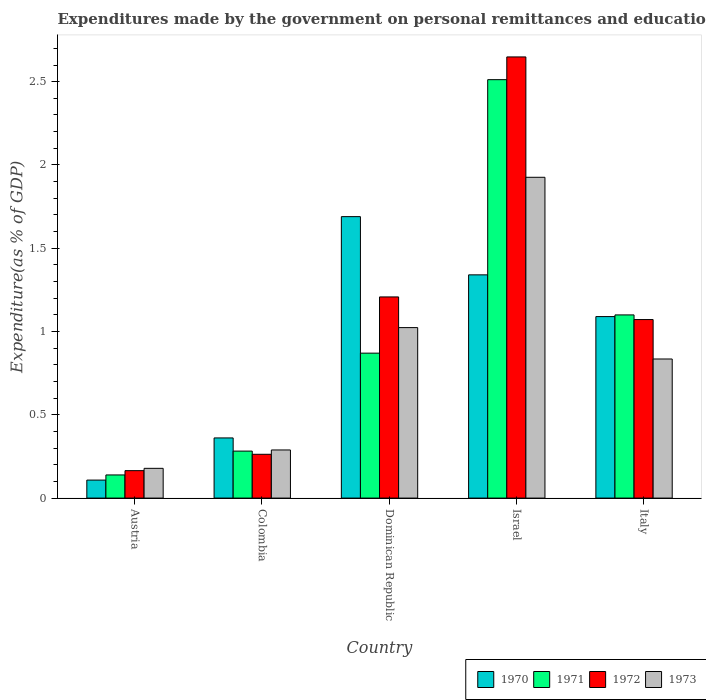How many different coloured bars are there?
Ensure brevity in your answer.  4. Are the number of bars per tick equal to the number of legend labels?
Provide a succinct answer. Yes. How many bars are there on the 1st tick from the left?
Make the answer very short. 4. How many bars are there on the 2nd tick from the right?
Make the answer very short. 4. What is the label of the 3rd group of bars from the left?
Provide a short and direct response. Dominican Republic. What is the expenditures made by the government on personal remittances and education in 1970 in Austria?
Your response must be concise. 0.11. Across all countries, what is the maximum expenditures made by the government on personal remittances and education in 1970?
Your response must be concise. 1.69. Across all countries, what is the minimum expenditures made by the government on personal remittances and education in 1973?
Give a very brief answer. 0.18. In which country was the expenditures made by the government on personal remittances and education in 1972 maximum?
Your answer should be very brief. Israel. What is the total expenditures made by the government on personal remittances and education in 1972 in the graph?
Provide a succinct answer. 5.36. What is the difference between the expenditures made by the government on personal remittances and education in 1970 in Israel and that in Italy?
Your answer should be compact. 0.25. What is the difference between the expenditures made by the government on personal remittances and education in 1973 in Italy and the expenditures made by the government on personal remittances and education in 1972 in Colombia?
Your answer should be very brief. 0.57. What is the average expenditures made by the government on personal remittances and education in 1973 per country?
Your answer should be compact. 0.85. What is the difference between the expenditures made by the government on personal remittances and education of/in 1972 and expenditures made by the government on personal remittances and education of/in 1971 in Colombia?
Provide a succinct answer. -0.02. What is the ratio of the expenditures made by the government on personal remittances and education in 1972 in Colombia to that in Dominican Republic?
Ensure brevity in your answer.  0.22. Is the difference between the expenditures made by the government on personal remittances and education in 1972 in Dominican Republic and Israel greater than the difference between the expenditures made by the government on personal remittances and education in 1971 in Dominican Republic and Israel?
Give a very brief answer. Yes. What is the difference between the highest and the second highest expenditures made by the government on personal remittances and education in 1973?
Offer a very short reply. -1.09. What is the difference between the highest and the lowest expenditures made by the government on personal remittances and education in 1973?
Make the answer very short. 1.75. In how many countries, is the expenditures made by the government on personal remittances and education in 1973 greater than the average expenditures made by the government on personal remittances and education in 1973 taken over all countries?
Provide a short and direct response. 2. What is the difference between two consecutive major ticks on the Y-axis?
Keep it short and to the point. 0.5. Are the values on the major ticks of Y-axis written in scientific E-notation?
Make the answer very short. No. Does the graph contain grids?
Give a very brief answer. No. How are the legend labels stacked?
Provide a succinct answer. Horizontal. What is the title of the graph?
Make the answer very short. Expenditures made by the government on personal remittances and education. What is the label or title of the X-axis?
Offer a terse response. Country. What is the label or title of the Y-axis?
Provide a succinct answer. Expenditure(as % of GDP). What is the Expenditure(as % of GDP) of 1970 in Austria?
Provide a succinct answer. 0.11. What is the Expenditure(as % of GDP) of 1971 in Austria?
Keep it short and to the point. 0.14. What is the Expenditure(as % of GDP) of 1972 in Austria?
Provide a short and direct response. 0.16. What is the Expenditure(as % of GDP) in 1973 in Austria?
Provide a short and direct response. 0.18. What is the Expenditure(as % of GDP) of 1970 in Colombia?
Give a very brief answer. 0.36. What is the Expenditure(as % of GDP) of 1971 in Colombia?
Your response must be concise. 0.28. What is the Expenditure(as % of GDP) in 1972 in Colombia?
Make the answer very short. 0.26. What is the Expenditure(as % of GDP) in 1973 in Colombia?
Offer a terse response. 0.29. What is the Expenditure(as % of GDP) of 1970 in Dominican Republic?
Your answer should be very brief. 1.69. What is the Expenditure(as % of GDP) of 1971 in Dominican Republic?
Offer a terse response. 0.87. What is the Expenditure(as % of GDP) in 1972 in Dominican Republic?
Make the answer very short. 1.21. What is the Expenditure(as % of GDP) in 1973 in Dominican Republic?
Your answer should be compact. 1.02. What is the Expenditure(as % of GDP) of 1970 in Israel?
Your answer should be compact. 1.34. What is the Expenditure(as % of GDP) of 1971 in Israel?
Your response must be concise. 2.51. What is the Expenditure(as % of GDP) of 1972 in Israel?
Ensure brevity in your answer.  2.65. What is the Expenditure(as % of GDP) of 1973 in Israel?
Your answer should be compact. 1.93. What is the Expenditure(as % of GDP) of 1970 in Italy?
Your answer should be compact. 1.09. What is the Expenditure(as % of GDP) in 1971 in Italy?
Offer a very short reply. 1.1. What is the Expenditure(as % of GDP) in 1972 in Italy?
Your response must be concise. 1.07. What is the Expenditure(as % of GDP) of 1973 in Italy?
Your response must be concise. 0.84. Across all countries, what is the maximum Expenditure(as % of GDP) of 1970?
Your answer should be very brief. 1.69. Across all countries, what is the maximum Expenditure(as % of GDP) in 1971?
Keep it short and to the point. 2.51. Across all countries, what is the maximum Expenditure(as % of GDP) in 1972?
Give a very brief answer. 2.65. Across all countries, what is the maximum Expenditure(as % of GDP) of 1973?
Your response must be concise. 1.93. Across all countries, what is the minimum Expenditure(as % of GDP) in 1970?
Give a very brief answer. 0.11. Across all countries, what is the minimum Expenditure(as % of GDP) in 1971?
Provide a short and direct response. 0.14. Across all countries, what is the minimum Expenditure(as % of GDP) in 1972?
Offer a very short reply. 0.16. Across all countries, what is the minimum Expenditure(as % of GDP) in 1973?
Your answer should be compact. 0.18. What is the total Expenditure(as % of GDP) in 1970 in the graph?
Provide a succinct answer. 4.59. What is the total Expenditure(as % of GDP) of 1971 in the graph?
Provide a succinct answer. 4.9. What is the total Expenditure(as % of GDP) of 1972 in the graph?
Provide a short and direct response. 5.36. What is the total Expenditure(as % of GDP) in 1973 in the graph?
Your answer should be very brief. 4.25. What is the difference between the Expenditure(as % of GDP) in 1970 in Austria and that in Colombia?
Make the answer very short. -0.25. What is the difference between the Expenditure(as % of GDP) in 1971 in Austria and that in Colombia?
Provide a short and direct response. -0.14. What is the difference between the Expenditure(as % of GDP) in 1972 in Austria and that in Colombia?
Your answer should be compact. -0.1. What is the difference between the Expenditure(as % of GDP) in 1973 in Austria and that in Colombia?
Your answer should be very brief. -0.11. What is the difference between the Expenditure(as % of GDP) in 1970 in Austria and that in Dominican Republic?
Offer a very short reply. -1.58. What is the difference between the Expenditure(as % of GDP) of 1971 in Austria and that in Dominican Republic?
Offer a very short reply. -0.73. What is the difference between the Expenditure(as % of GDP) of 1972 in Austria and that in Dominican Republic?
Offer a terse response. -1.04. What is the difference between the Expenditure(as % of GDP) in 1973 in Austria and that in Dominican Republic?
Make the answer very short. -0.84. What is the difference between the Expenditure(as % of GDP) of 1970 in Austria and that in Israel?
Your answer should be very brief. -1.23. What is the difference between the Expenditure(as % of GDP) in 1971 in Austria and that in Israel?
Offer a very short reply. -2.37. What is the difference between the Expenditure(as % of GDP) of 1972 in Austria and that in Israel?
Offer a terse response. -2.48. What is the difference between the Expenditure(as % of GDP) of 1973 in Austria and that in Israel?
Ensure brevity in your answer.  -1.75. What is the difference between the Expenditure(as % of GDP) in 1970 in Austria and that in Italy?
Keep it short and to the point. -0.98. What is the difference between the Expenditure(as % of GDP) in 1971 in Austria and that in Italy?
Provide a short and direct response. -0.96. What is the difference between the Expenditure(as % of GDP) in 1972 in Austria and that in Italy?
Your response must be concise. -0.91. What is the difference between the Expenditure(as % of GDP) of 1973 in Austria and that in Italy?
Offer a very short reply. -0.66. What is the difference between the Expenditure(as % of GDP) in 1970 in Colombia and that in Dominican Republic?
Make the answer very short. -1.33. What is the difference between the Expenditure(as % of GDP) of 1971 in Colombia and that in Dominican Republic?
Provide a short and direct response. -0.59. What is the difference between the Expenditure(as % of GDP) of 1972 in Colombia and that in Dominican Republic?
Ensure brevity in your answer.  -0.94. What is the difference between the Expenditure(as % of GDP) of 1973 in Colombia and that in Dominican Republic?
Provide a short and direct response. -0.73. What is the difference between the Expenditure(as % of GDP) in 1970 in Colombia and that in Israel?
Give a very brief answer. -0.98. What is the difference between the Expenditure(as % of GDP) of 1971 in Colombia and that in Israel?
Provide a succinct answer. -2.23. What is the difference between the Expenditure(as % of GDP) of 1972 in Colombia and that in Israel?
Provide a short and direct response. -2.39. What is the difference between the Expenditure(as % of GDP) in 1973 in Colombia and that in Israel?
Keep it short and to the point. -1.64. What is the difference between the Expenditure(as % of GDP) in 1970 in Colombia and that in Italy?
Your response must be concise. -0.73. What is the difference between the Expenditure(as % of GDP) of 1971 in Colombia and that in Italy?
Ensure brevity in your answer.  -0.82. What is the difference between the Expenditure(as % of GDP) of 1972 in Colombia and that in Italy?
Your answer should be compact. -0.81. What is the difference between the Expenditure(as % of GDP) in 1973 in Colombia and that in Italy?
Provide a short and direct response. -0.55. What is the difference between the Expenditure(as % of GDP) in 1970 in Dominican Republic and that in Israel?
Provide a succinct answer. 0.35. What is the difference between the Expenditure(as % of GDP) in 1971 in Dominican Republic and that in Israel?
Your answer should be very brief. -1.64. What is the difference between the Expenditure(as % of GDP) in 1972 in Dominican Republic and that in Israel?
Ensure brevity in your answer.  -1.44. What is the difference between the Expenditure(as % of GDP) of 1973 in Dominican Republic and that in Israel?
Offer a terse response. -0.9. What is the difference between the Expenditure(as % of GDP) of 1970 in Dominican Republic and that in Italy?
Your answer should be very brief. 0.6. What is the difference between the Expenditure(as % of GDP) of 1971 in Dominican Republic and that in Italy?
Keep it short and to the point. -0.23. What is the difference between the Expenditure(as % of GDP) of 1972 in Dominican Republic and that in Italy?
Make the answer very short. 0.14. What is the difference between the Expenditure(as % of GDP) in 1973 in Dominican Republic and that in Italy?
Your response must be concise. 0.19. What is the difference between the Expenditure(as % of GDP) in 1970 in Israel and that in Italy?
Make the answer very short. 0.25. What is the difference between the Expenditure(as % of GDP) in 1971 in Israel and that in Italy?
Offer a terse response. 1.41. What is the difference between the Expenditure(as % of GDP) of 1972 in Israel and that in Italy?
Make the answer very short. 1.58. What is the difference between the Expenditure(as % of GDP) in 1973 in Israel and that in Italy?
Keep it short and to the point. 1.09. What is the difference between the Expenditure(as % of GDP) in 1970 in Austria and the Expenditure(as % of GDP) in 1971 in Colombia?
Give a very brief answer. -0.17. What is the difference between the Expenditure(as % of GDP) of 1970 in Austria and the Expenditure(as % of GDP) of 1972 in Colombia?
Provide a succinct answer. -0.15. What is the difference between the Expenditure(as % of GDP) in 1970 in Austria and the Expenditure(as % of GDP) in 1973 in Colombia?
Your response must be concise. -0.18. What is the difference between the Expenditure(as % of GDP) in 1971 in Austria and the Expenditure(as % of GDP) in 1972 in Colombia?
Provide a succinct answer. -0.12. What is the difference between the Expenditure(as % of GDP) in 1971 in Austria and the Expenditure(as % of GDP) in 1973 in Colombia?
Offer a very short reply. -0.15. What is the difference between the Expenditure(as % of GDP) of 1972 in Austria and the Expenditure(as % of GDP) of 1973 in Colombia?
Provide a succinct answer. -0.12. What is the difference between the Expenditure(as % of GDP) of 1970 in Austria and the Expenditure(as % of GDP) of 1971 in Dominican Republic?
Give a very brief answer. -0.76. What is the difference between the Expenditure(as % of GDP) in 1970 in Austria and the Expenditure(as % of GDP) in 1972 in Dominican Republic?
Keep it short and to the point. -1.1. What is the difference between the Expenditure(as % of GDP) of 1970 in Austria and the Expenditure(as % of GDP) of 1973 in Dominican Republic?
Your answer should be very brief. -0.92. What is the difference between the Expenditure(as % of GDP) in 1971 in Austria and the Expenditure(as % of GDP) in 1972 in Dominican Republic?
Make the answer very short. -1.07. What is the difference between the Expenditure(as % of GDP) in 1971 in Austria and the Expenditure(as % of GDP) in 1973 in Dominican Republic?
Provide a succinct answer. -0.88. What is the difference between the Expenditure(as % of GDP) of 1972 in Austria and the Expenditure(as % of GDP) of 1973 in Dominican Republic?
Provide a succinct answer. -0.86. What is the difference between the Expenditure(as % of GDP) in 1970 in Austria and the Expenditure(as % of GDP) in 1971 in Israel?
Your answer should be very brief. -2.4. What is the difference between the Expenditure(as % of GDP) of 1970 in Austria and the Expenditure(as % of GDP) of 1972 in Israel?
Your answer should be compact. -2.54. What is the difference between the Expenditure(as % of GDP) in 1970 in Austria and the Expenditure(as % of GDP) in 1973 in Israel?
Make the answer very short. -1.82. What is the difference between the Expenditure(as % of GDP) of 1971 in Austria and the Expenditure(as % of GDP) of 1972 in Israel?
Make the answer very short. -2.51. What is the difference between the Expenditure(as % of GDP) of 1971 in Austria and the Expenditure(as % of GDP) of 1973 in Israel?
Offer a terse response. -1.79. What is the difference between the Expenditure(as % of GDP) of 1972 in Austria and the Expenditure(as % of GDP) of 1973 in Israel?
Provide a short and direct response. -1.76. What is the difference between the Expenditure(as % of GDP) in 1970 in Austria and the Expenditure(as % of GDP) in 1971 in Italy?
Keep it short and to the point. -0.99. What is the difference between the Expenditure(as % of GDP) in 1970 in Austria and the Expenditure(as % of GDP) in 1972 in Italy?
Your response must be concise. -0.96. What is the difference between the Expenditure(as % of GDP) in 1970 in Austria and the Expenditure(as % of GDP) in 1973 in Italy?
Your answer should be very brief. -0.73. What is the difference between the Expenditure(as % of GDP) of 1971 in Austria and the Expenditure(as % of GDP) of 1972 in Italy?
Keep it short and to the point. -0.93. What is the difference between the Expenditure(as % of GDP) in 1971 in Austria and the Expenditure(as % of GDP) in 1973 in Italy?
Make the answer very short. -0.7. What is the difference between the Expenditure(as % of GDP) of 1972 in Austria and the Expenditure(as % of GDP) of 1973 in Italy?
Your answer should be compact. -0.67. What is the difference between the Expenditure(as % of GDP) in 1970 in Colombia and the Expenditure(as % of GDP) in 1971 in Dominican Republic?
Make the answer very short. -0.51. What is the difference between the Expenditure(as % of GDP) in 1970 in Colombia and the Expenditure(as % of GDP) in 1972 in Dominican Republic?
Keep it short and to the point. -0.85. What is the difference between the Expenditure(as % of GDP) in 1970 in Colombia and the Expenditure(as % of GDP) in 1973 in Dominican Republic?
Make the answer very short. -0.66. What is the difference between the Expenditure(as % of GDP) in 1971 in Colombia and the Expenditure(as % of GDP) in 1972 in Dominican Republic?
Offer a terse response. -0.93. What is the difference between the Expenditure(as % of GDP) of 1971 in Colombia and the Expenditure(as % of GDP) of 1973 in Dominican Republic?
Provide a short and direct response. -0.74. What is the difference between the Expenditure(as % of GDP) in 1972 in Colombia and the Expenditure(as % of GDP) in 1973 in Dominican Republic?
Provide a short and direct response. -0.76. What is the difference between the Expenditure(as % of GDP) of 1970 in Colombia and the Expenditure(as % of GDP) of 1971 in Israel?
Provide a succinct answer. -2.15. What is the difference between the Expenditure(as % of GDP) in 1970 in Colombia and the Expenditure(as % of GDP) in 1972 in Israel?
Ensure brevity in your answer.  -2.29. What is the difference between the Expenditure(as % of GDP) of 1970 in Colombia and the Expenditure(as % of GDP) of 1973 in Israel?
Give a very brief answer. -1.56. What is the difference between the Expenditure(as % of GDP) in 1971 in Colombia and the Expenditure(as % of GDP) in 1972 in Israel?
Your answer should be very brief. -2.37. What is the difference between the Expenditure(as % of GDP) in 1971 in Colombia and the Expenditure(as % of GDP) in 1973 in Israel?
Your answer should be very brief. -1.64. What is the difference between the Expenditure(as % of GDP) in 1972 in Colombia and the Expenditure(as % of GDP) in 1973 in Israel?
Your response must be concise. -1.66. What is the difference between the Expenditure(as % of GDP) in 1970 in Colombia and the Expenditure(as % of GDP) in 1971 in Italy?
Give a very brief answer. -0.74. What is the difference between the Expenditure(as % of GDP) in 1970 in Colombia and the Expenditure(as % of GDP) in 1972 in Italy?
Offer a terse response. -0.71. What is the difference between the Expenditure(as % of GDP) in 1970 in Colombia and the Expenditure(as % of GDP) in 1973 in Italy?
Offer a terse response. -0.47. What is the difference between the Expenditure(as % of GDP) of 1971 in Colombia and the Expenditure(as % of GDP) of 1972 in Italy?
Your response must be concise. -0.79. What is the difference between the Expenditure(as % of GDP) in 1971 in Colombia and the Expenditure(as % of GDP) in 1973 in Italy?
Offer a terse response. -0.55. What is the difference between the Expenditure(as % of GDP) of 1972 in Colombia and the Expenditure(as % of GDP) of 1973 in Italy?
Make the answer very short. -0.57. What is the difference between the Expenditure(as % of GDP) of 1970 in Dominican Republic and the Expenditure(as % of GDP) of 1971 in Israel?
Offer a terse response. -0.82. What is the difference between the Expenditure(as % of GDP) of 1970 in Dominican Republic and the Expenditure(as % of GDP) of 1972 in Israel?
Your answer should be very brief. -0.96. What is the difference between the Expenditure(as % of GDP) of 1970 in Dominican Republic and the Expenditure(as % of GDP) of 1973 in Israel?
Make the answer very short. -0.24. What is the difference between the Expenditure(as % of GDP) of 1971 in Dominican Republic and the Expenditure(as % of GDP) of 1972 in Israel?
Your response must be concise. -1.78. What is the difference between the Expenditure(as % of GDP) of 1971 in Dominican Republic and the Expenditure(as % of GDP) of 1973 in Israel?
Your answer should be very brief. -1.06. What is the difference between the Expenditure(as % of GDP) of 1972 in Dominican Republic and the Expenditure(as % of GDP) of 1973 in Israel?
Provide a succinct answer. -0.72. What is the difference between the Expenditure(as % of GDP) in 1970 in Dominican Republic and the Expenditure(as % of GDP) in 1971 in Italy?
Keep it short and to the point. 0.59. What is the difference between the Expenditure(as % of GDP) in 1970 in Dominican Republic and the Expenditure(as % of GDP) in 1972 in Italy?
Give a very brief answer. 0.62. What is the difference between the Expenditure(as % of GDP) of 1970 in Dominican Republic and the Expenditure(as % of GDP) of 1973 in Italy?
Your answer should be very brief. 0.85. What is the difference between the Expenditure(as % of GDP) of 1971 in Dominican Republic and the Expenditure(as % of GDP) of 1972 in Italy?
Offer a very short reply. -0.2. What is the difference between the Expenditure(as % of GDP) in 1971 in Dominican Republic and the Expenditure(as % of GDP) in 1973 in Italy?
Provide a succinct answer. 0.04. What is the difference between the Expenditure(as % of GDP) in 1972 in Dominican Republic and the Expenditure(as % of GDP) in 1973 in Italy?
Give a very brief answer. 0.37. What is the difference between the Expenditure(as % of GDP) of 1970 in Israel and the Expenditure(as % of GDP) of 1971 in Italy?
Your response must be concise. 0.24. What is the difference between the Expenditure(as % of GDP) of 1970 in Israel and the Expenditure(as % of GDP) of 1972 in Italy?
Your answer should be compact. 0.27. What is the difference between the Expenditure(as % of GDP) in 1970 in Israel and the Expenditure(as % of GDP) in 1973 in Italy?
Provide a short and direct response. 0.51. What is the difference between the Expenditure(as % of GDP) of 1971 in Israel and the Expenditure(as % of GDP) of 1972 in Italy?
Give a very brief answer. 1.44. What is the difference between the Expenditure(as % of GDP) in 1971 in Israel and the Expenditure(as % of GDP) in 1973 in Italy?
Offer a terse response. 1.68. What is the difference between the Expenditure(as % of GDP) of 1972 in Israel and the Expenditure(as % of GDP) of 1973 in Italy?
Your response must be concise. 1.81. What is the average Expenditure(as % of GDP) in 1970 per country?
Offer a very short reply. 0.92. What is the average Expenditure(as % of GDP) in 1971 per country?
Make the answer very short. 0.98. What is the average Expenditure(as % of GDP) in 1972 per country?
Provide a succinct answer. 1.07. What is the average Expenditure(as % of GDP) in 1973 per country?
Your answer should be very brief. 0.85. What is the difference between the Expenditure(as % of GDP) in 1970 and Expenditure(as % of GDP) in 1971 in Austria?
Give a very brief answer. -0.03. What is the difference between the Expenditure(as % of GDP) of 1970 and Expenditure(as % of GDP) of 1972 in Austria?
Ensure brevity in your answer.  -0.06. What is the difference between the Expenditure(as % of GDP) of 1970 and Expenditure(as % of GDP) of 1973 in Austria?
Ensure brevity in your answer.  -0.07. What is the difference between the Expenditure(as % of GDP) of 1971 and Expenditure(as % of GDP) of 1972 in Austria?
Keep it short and to the point. -0.03. What is the difference between the Expenditure(as % of GDP) in 1971 and Expenditure(as % of GDP) in 1973 in Austria?
Make the answer very short. -0.04. What is the difference between the Expenditure(as % of GDP) of 1972 and Expenditure(as % of GDP) of 1973 in Austria?
Provide a succinct answer. -0.01. What is the difference between the Expenditure(as % of GDP) in 1970 and Expenditure(as % of GDP) in 1971 in Colombia?
Provide a short and direct response. 0.08. What is the difference between the Expenditure(as % of GDP) in 1970 and Expenditure(as % of GDP) in 1972 in Colombia?
Ensure brevity in your answer.  0.1. What is the difference between the Expenditure(as % of GDP) in 1970 and Expenditure(as % of GDP) in 1973 in Colombia?
Make the answer very short. 0.07. What is the difference between the Expenditure(as % of GDP) of 1971 and Expenditure(as % of GDP) of 1972 in Colombia?
Ensure brevity in your answer.  0.02. What is the difference between the Expenditure(as % of GDP) of 1971 and Expenditure(as % of GDP) of 1973 in Colombia?
Your answer should be compact. -0.01. What is the difference between the Expenditure(as % of GDP) in 1972 and Expenditure(as % of GDP) in 1973 in Colombia?
Offer a very short reply. -0.03. What is the difference between the Expenditure(as % of GDP) in 1970 and Expenditure(as % of GDP) in 1971 in Dominican Republic?
Your response must be concise. 0.82. What is the difference between the Expenditure(as % of GDP) in 1970 and Expenditure(as % of GDP) in 1972 in Dominican Republic?
Your answer should be compact. 0.48. What is the difference between the Expenditure(as % of GDP) in 1970 and Expenditure(as % of GDP) in 1973 in Dominican Republic?
Keep it short and to the point. 0.67. What is the difference between the Expenditure(as % of GDP) in 1971 and Expenditure(as % of GDP) in 1972 in Dominican Republic?
Offer a terse response. -0.34. What is the difference between the Expenditure(as % of GDP) of 1971 and Expenditure(as % of GDP) of 1973 in Dominican Republic?
Ensure brevity in your answer.  -0.15. What is the difference between the Expenditure(as % of GDP) in 1972 and Expenditure(as % of GDP) in 1973 in Dominican Republic?
Make the answer very short. 0.18. What is the difference between the Expenditure(as % of GDP) of 1970 and Expenditure(as % of GDP) of 1971 in Israel?
Ensure brevity in your answer.  -1.17. What is the difference between the Expenditure(as % of GDP) in 1970 and Expenditure(as % of GDP) in 1972 in Israel?
Ensure brevity in your answer.  -1.31. What is the difference between the Expenditure(as % of GDP) of 1970 and Expenditure(as % of GDP) of 1973 in Israel?
Make the answer very short. -0.59. What is the difference between the Expenditure(as % of GDP) of 1971 and Expenditure(as % of GDP) of 1972 in Israel?
Give a very brief answer. -0.14. What is the difference between the Expenditure(as % of GDP) in 1971 and Expenditure(as % of GDP) in 1973 in Israel?
Provide a short and direct response. 0.59. What is the difference between the Expenditure(as % of GDP) in 1972 and Expenditure(as % of GDP) in 1973 in Israel?
Provide a succinct answer. 0.72. What is the difference between the Expenditure(as % of GDP) of 1970 and Expenditure(as % of GDP) of 1971 in Italy?
Your answer should be very brief. -0.01. What is the difference between the Expenditure(as % of GDP) of 1970 and Expenditure(as % of GDP) of 1972 in Italy?
Your response must be concise. 0.02. What is the difference between the Expenditure(as % of GDP) of 1970 and Expenditure(as % of GDP) of 1973 in Italy?
Your response must be concise. 0.25. What is the difference between the Expenditure(as % of GDP) of 1971 and Expenditure(as % of GDP) of 1972 in Italy?
Offer a terse response. 0.03. What is the difference between the Expenditure(as % of GDP) in 1971 and Expenditure(as % of GDP) in 1973 in Italy?
Your answer should be compact. 0.26. What is the difference between the Expenditure(as % of GDP) of 1972 and Expenditure(as % of GDP) of 1973 in Italy?
Give a very brief answer. 0.24. What is the ratio of the Expenditure(as % of GDP) of 1970 in Austria to that in Colombia?
Offer a very short reply. 0.3. What is the ratio of the Expenditure(as % of GDP) of 1971 in Austria to that in Colombia?
Keep it short and to the point. 0.49. What is the ratio of the Expenditure(as % of GDP) in 1972 in Austria to that in Colombia?
Ensure brevity in your answer.  0.63. What is the ratio of the Expenditure(as % of GDP) in 1973 in Austria to that in Colombia?
Provide a succinct answer. 0.62. What is the ratio of the Expenditure(as % of GDP) of 1970 in Austria to that in Dominican Republic?
Your answer should be very brief. 0.06. What is the ratio of the Expenditure(as % of GDP) of 1971 in Austria to that in Dominican Republic?
Give a very brief answer. 0.16. What is the ratio of the Expenditure(as % of GDP) of 1972 in Austria to that in Dominican Republic?
Offer a terse response. 0.14. What is the ratio of the Expenditure(as % of GDP) in 1973 in Austria to that in Dominican Republic?
Your answer should be compact. 0.17. What is the ratio of the Expenditure(as % of GDP) in 1970 in Austria to that in Israel?
Provide a short and direct response. 0.08. What is the ratio of the Expenditure(as % of GDP) of 1971 in Austria to that in Israel?
Your answer should be very brief. 0.06. What is the ratio of the Expenditure(as % of GDP) of 1972 in Austria to that in Israel?
Make the answer very short. 0.06. What is the ratio of the Expenditure(as % of GDP) of 1973 in Austria to that in Israel?
Provide a succinct answer. 0.09. What is the ratio of the Expenditure(as % of GDP) in 1970 in Austria to that in Italy?
Provide a short and direct response. 0.1. What is the ratio of the Expenditure(as % of GDP) in 1971 in Austria to that in Italy?
Your response must be concise. 0.13. What is the ratio of the Expenditure(as % of GDP) in 1972 in Austria to that in Italy?
Offer a terse response. 0.15. What is the ratio of the Expenditure(as % of GDP) in 1973 in Austria to that in Italy?
Make the answer very short. 0.21. What is the ratio of the Expenditure(as % of GDP) in 1970 in Colombia to that in Dominican Republic?
Your answer should be compact. 0.21. What is the ratio of the Expenditure(as % of GDP) in 1971 in Colombia to that in Dominican Republic?
Give a very brief answer. 0.32. What is the ratio of the Expenditure(as % of GDP) of 1972 in Colombia to that in Dominican Republic?
Provide a succinct answer. 0.22. What is the ratio of the Expenditure(as % of GDP) of 1973 in Colombia to that in Dominican Republic?
Keep it short and to the point. 0.28. What is the ratio of the Expenditure(as % of GDP) in 1970 in Colombia to that in Israel?
Make the answer very short. 0.27. What is the ratio of the Expenditure(as % of GDP) of 1971 in Colombia to that in Israel?
Keep it short and to the point. 0.11. What is the ratio of the Expenditure(as % of GDP) in 1972 in Colombia to that in Israel?
Ensure brevity in your answer.  0.1. What is the ratio of the Expenditure(as % of GDP) in 1970 in Colombia to that in Italy?
Offer a terse response. 0.33. What is the ratio of the Expenditure(as % of GDP) of 1971 in Colombia to that in Italy?
Your response must be concise. 0.26. What is the ratio of the Expenditure(as % of GDP) of 1972 in Colombia to that in Italy?
Give a very brief answer. 0.25. What is the ratio of the Expenditure(as % of GDP) in 1973 in Colombia to that in Italy?
Provide a short and direct response. 0.35. What is the ratio of the Expenditure(as % of GDP) in 1970 in Dominican Republic to that in Israel?
Keep it short and to the point. 1.26. What is the ratio of the Expenditure(as % of GDP) of 1971 in Dominican Republic to that in Israel?
Give a very brief answer. 0.35. What is the ratio of the Expenditure(as % of GDP) of 1972 in Dominican Republic to that in Israel?
Ensure brevity in your answer.  0.46. What is the ratio of the Expenditure(as % of GDP) of 1973 in Dominican Republic to that in Israel?
Your answer should be very brief. 0.53. What is the ratio of the Expenditure(as % of GDP) in 1970 in Dominican Republic to that in Italy?
Ensure brevity in your answer.  1.55. What is the ratio of the Expenditure(as % of GDP) in 1971 in Dominican Republic to that in Italy?
Provide a succinct answer. 0.79. What is the ratio of the Expenditure(as % of GDP) in 1972 in Dominican Republic to that in Italy?
Give a very brief answer. 1.13. What is the ratio of the Expenditure(as % of GDP) in 1973 in Dominican Republic to that in Italy?
Provide a short and direct response. 1.23. What is the ratio of the Expenditure(as % of GDP) in 1970 in Israel to that in Italy?
Offer a terse response. 1.23. What is the ratio of the Expenditure(as % of GDP) of 1971 in Israel to that in Italy?
Provide a short and direct response. 2.28. What is the ratio of the Expenditure(as % of GDP) of 1972 in Israel to that in Italy?
Give a very brief answer. 2.47. What is the ratio of the Expenditure(as % of GDP) in 1973 in Israel to that in Italy?
Ensure brevity in your answer.  2.31. What is the difference between the highest and the second highest Expenditure(as % of GDP) in 1970?
Provide a short and direct response. 0.35. What is the difference between the highest and the second highest Expenditure(as % of GDP) of 1971?
Provide a short and direct response. 1.41. What is the difference between the highest and the second highest Expenditure(as % of GDP) of 1972?
Your answer should be very brief. 1.44. What is the difference between the highest and the second highest Expenditure(as % of GDP) in 1973?
Keep it short and to the point. 0.9. What is the difference between the highest and the lowest Expenditure(as % of GDP) of 1970?
Ensure brevity in your answer.  1.58. What is the difference between the highest and the lowest Expenditure(as % of GDP) in 1971?
Make the answer very short. 2.37. What is the difference between the highest and the lowest Expenditure(as % of GDP) in 1972?
Offer a very short reply. 2.48. What is the difference between the highest and the lowest Expenditure(as % of GDP) of 1973?
Your answer should be very brief. 1.75. 